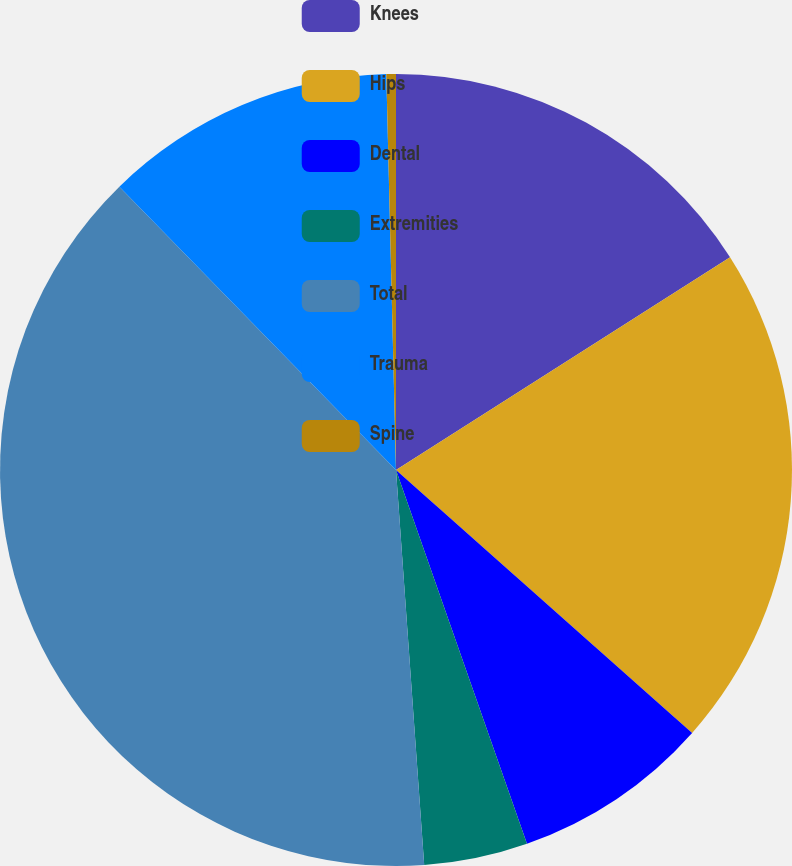<chart> <loc_0><loc_0><loc_500><loc_500><pie_chart><fcel>Knees<fcel>Hips<fcel>Dental<fcel>Extremities<fcel>Total<fcel>Trauma<fcel>Spine<nl><fcel>15.98%<fcel>20.58%<fcel>8.08%<fcel>4.23%<fcel>38.83%<fcel>11.92%<fcel>0.39%<nl></chart> 